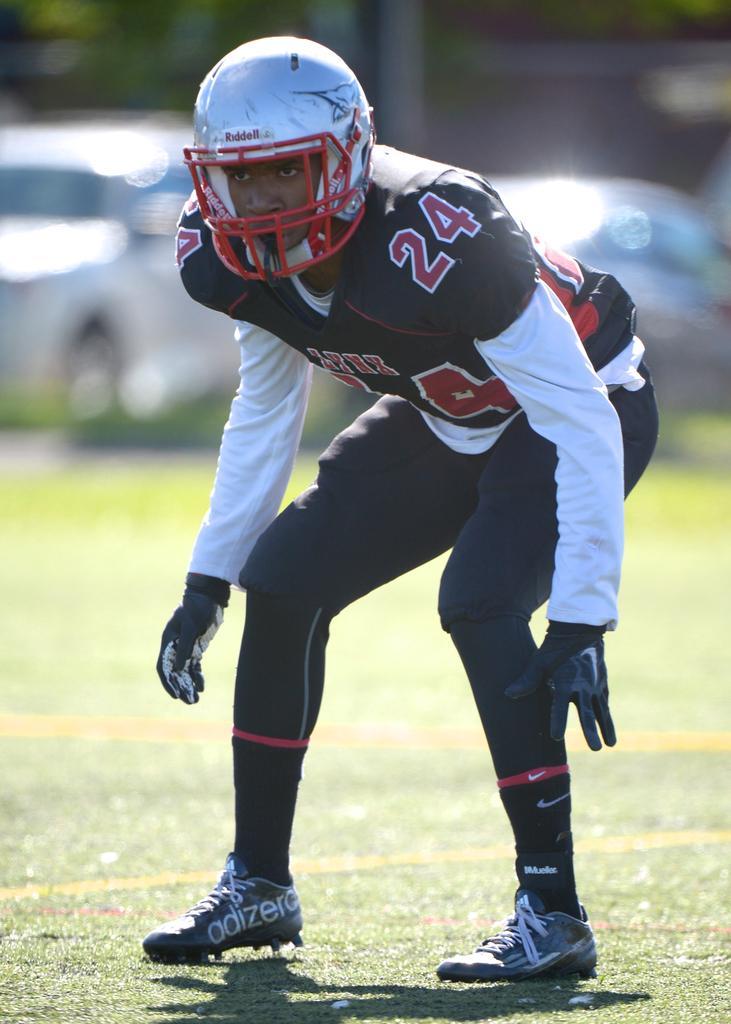How would you summarize this image in a sentence or two? In the picture,there is a sports man standing on the ground. He is wearing a helmet and he is standing in a squatting position,the background of the man is blur. 